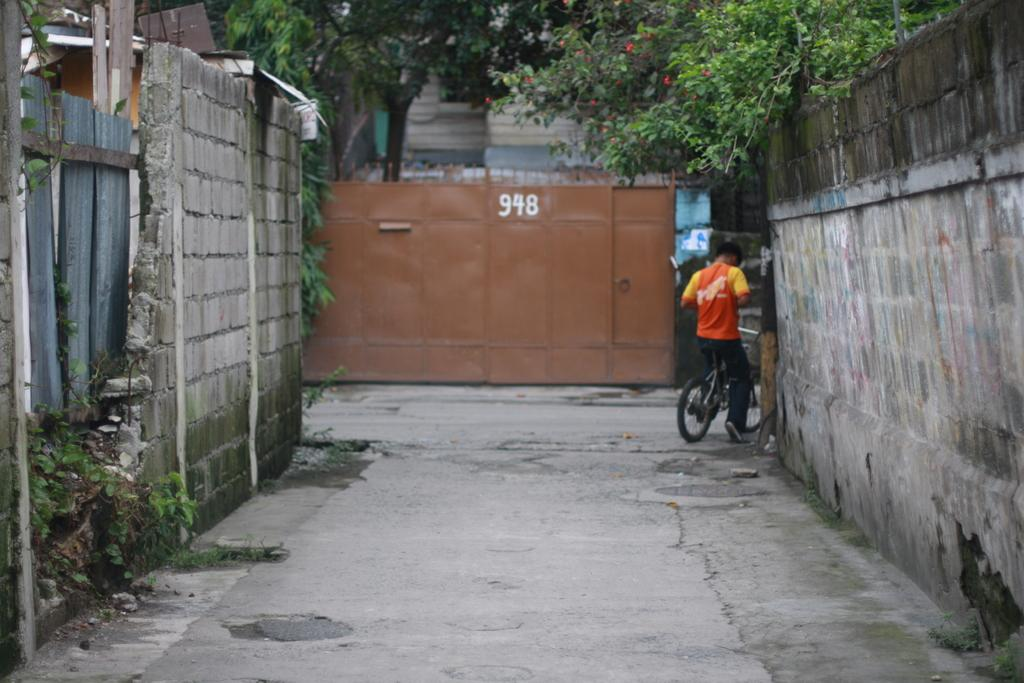<image>
Give a short and clear explanation of the subsequent image. A man on a bicycle is in an alley in front of a dumpster with the number 948 on it. 